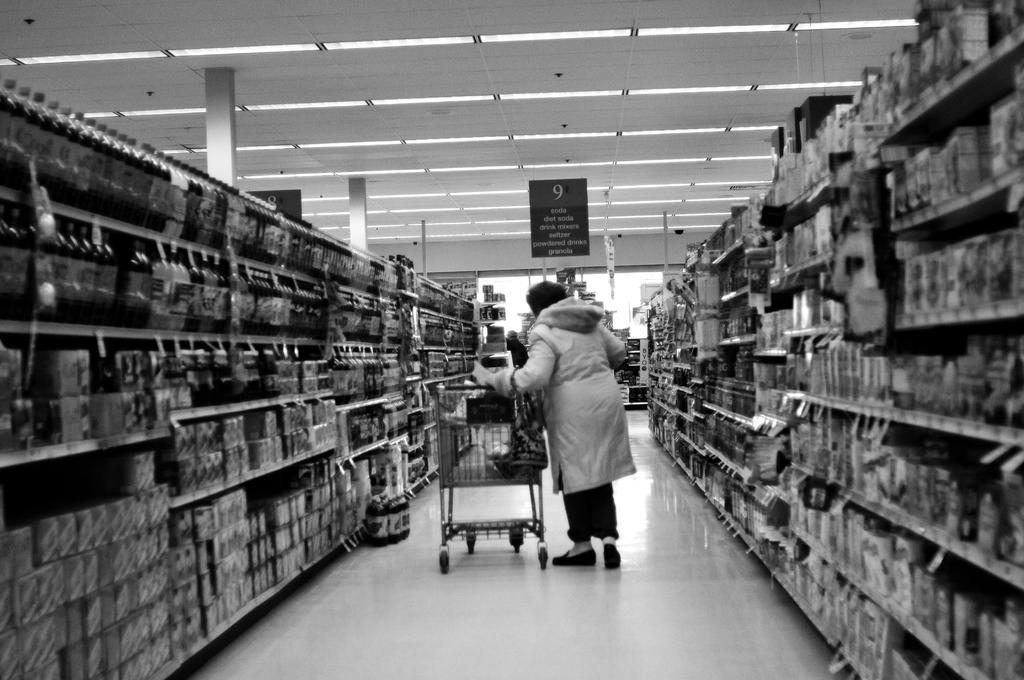Provide a one-sentence caption for the provided image. A woman looking through aisle 9 of a grocery store. 